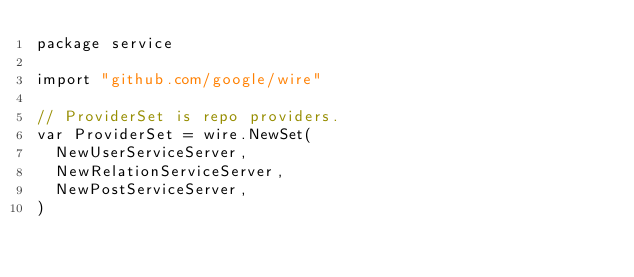<code> <loc_0><loc_0><loc_500><loc_500><_Go_>package service

import "github.com/google/wire"

// ProviderSet is repo providers.
var ProviderSet = wire.NewSet(
	NewUserServiceServer,
	NewRelationServiceServer,
	NewPostServiceServer,
)
</code> 